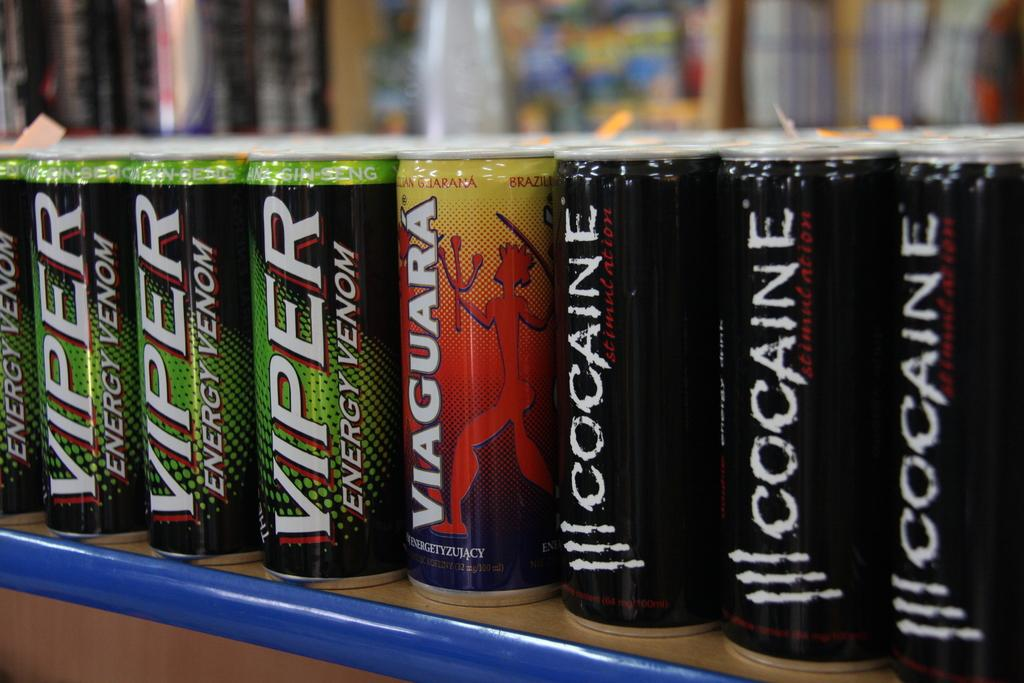Provide a one-sentence caption for the provided image. The beverage in the green and black can is called Viper Energy Venom. 